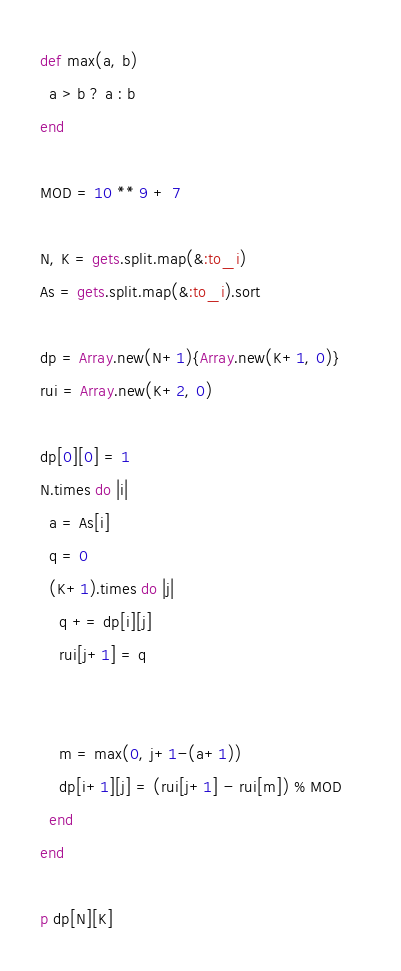<code> <loc_0><loc_0><loc_500><loc_500><_Ruby_>def max(a, b)
  a > b ? a : b
end

MOD = 10 ** 9 + 7

N, K = gets.split.map(&:to_i)
As = gets.split.map(&:to_i).sort

dp = Array.new(N+1){Array.new(K+1, 0)}
rui = Array.new(K+2, 0)

dp[0][0] = 1
N.times do |i|
  a = As[i]
  q = 0
  (K+1).times do |j|
    q += dp[i][j]
    rui[j+1] = q
    
    
    m = max(0, j+1-(a+1))
    dp[i+1][j] = (rui[j+1] - rui[m]) % MOD    
  end
end

p dp[N][K]
</code> 